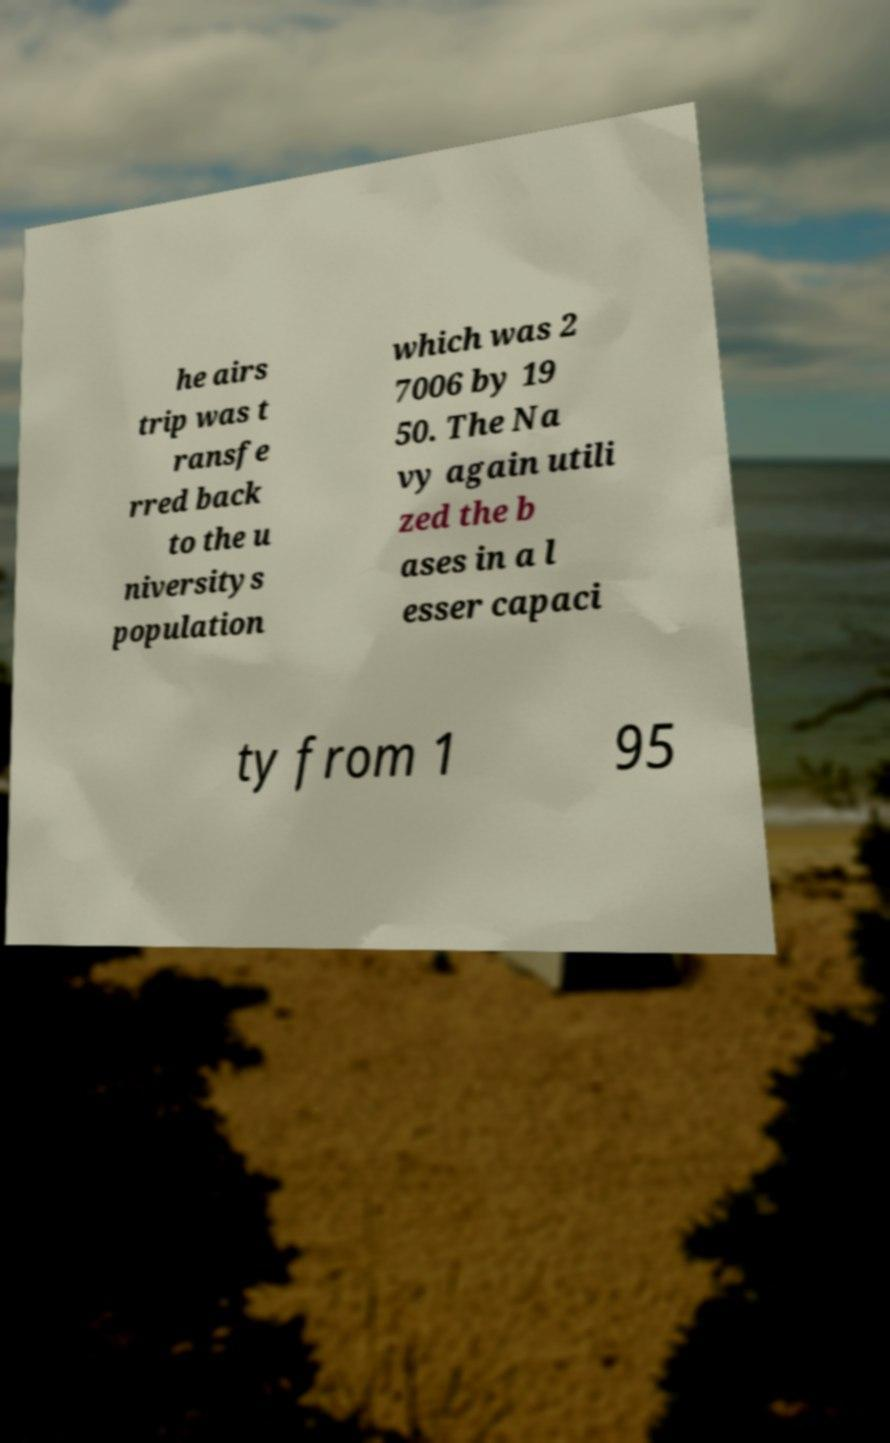What messages or text are displayed in this image? I need them in a readable, typed format. he airs trip was t ransfe rred back to the u niversitys population which was 2 7006 by 19 50. The Na vy again utili zed the b ases in a l esser capaci ty from 1 95 